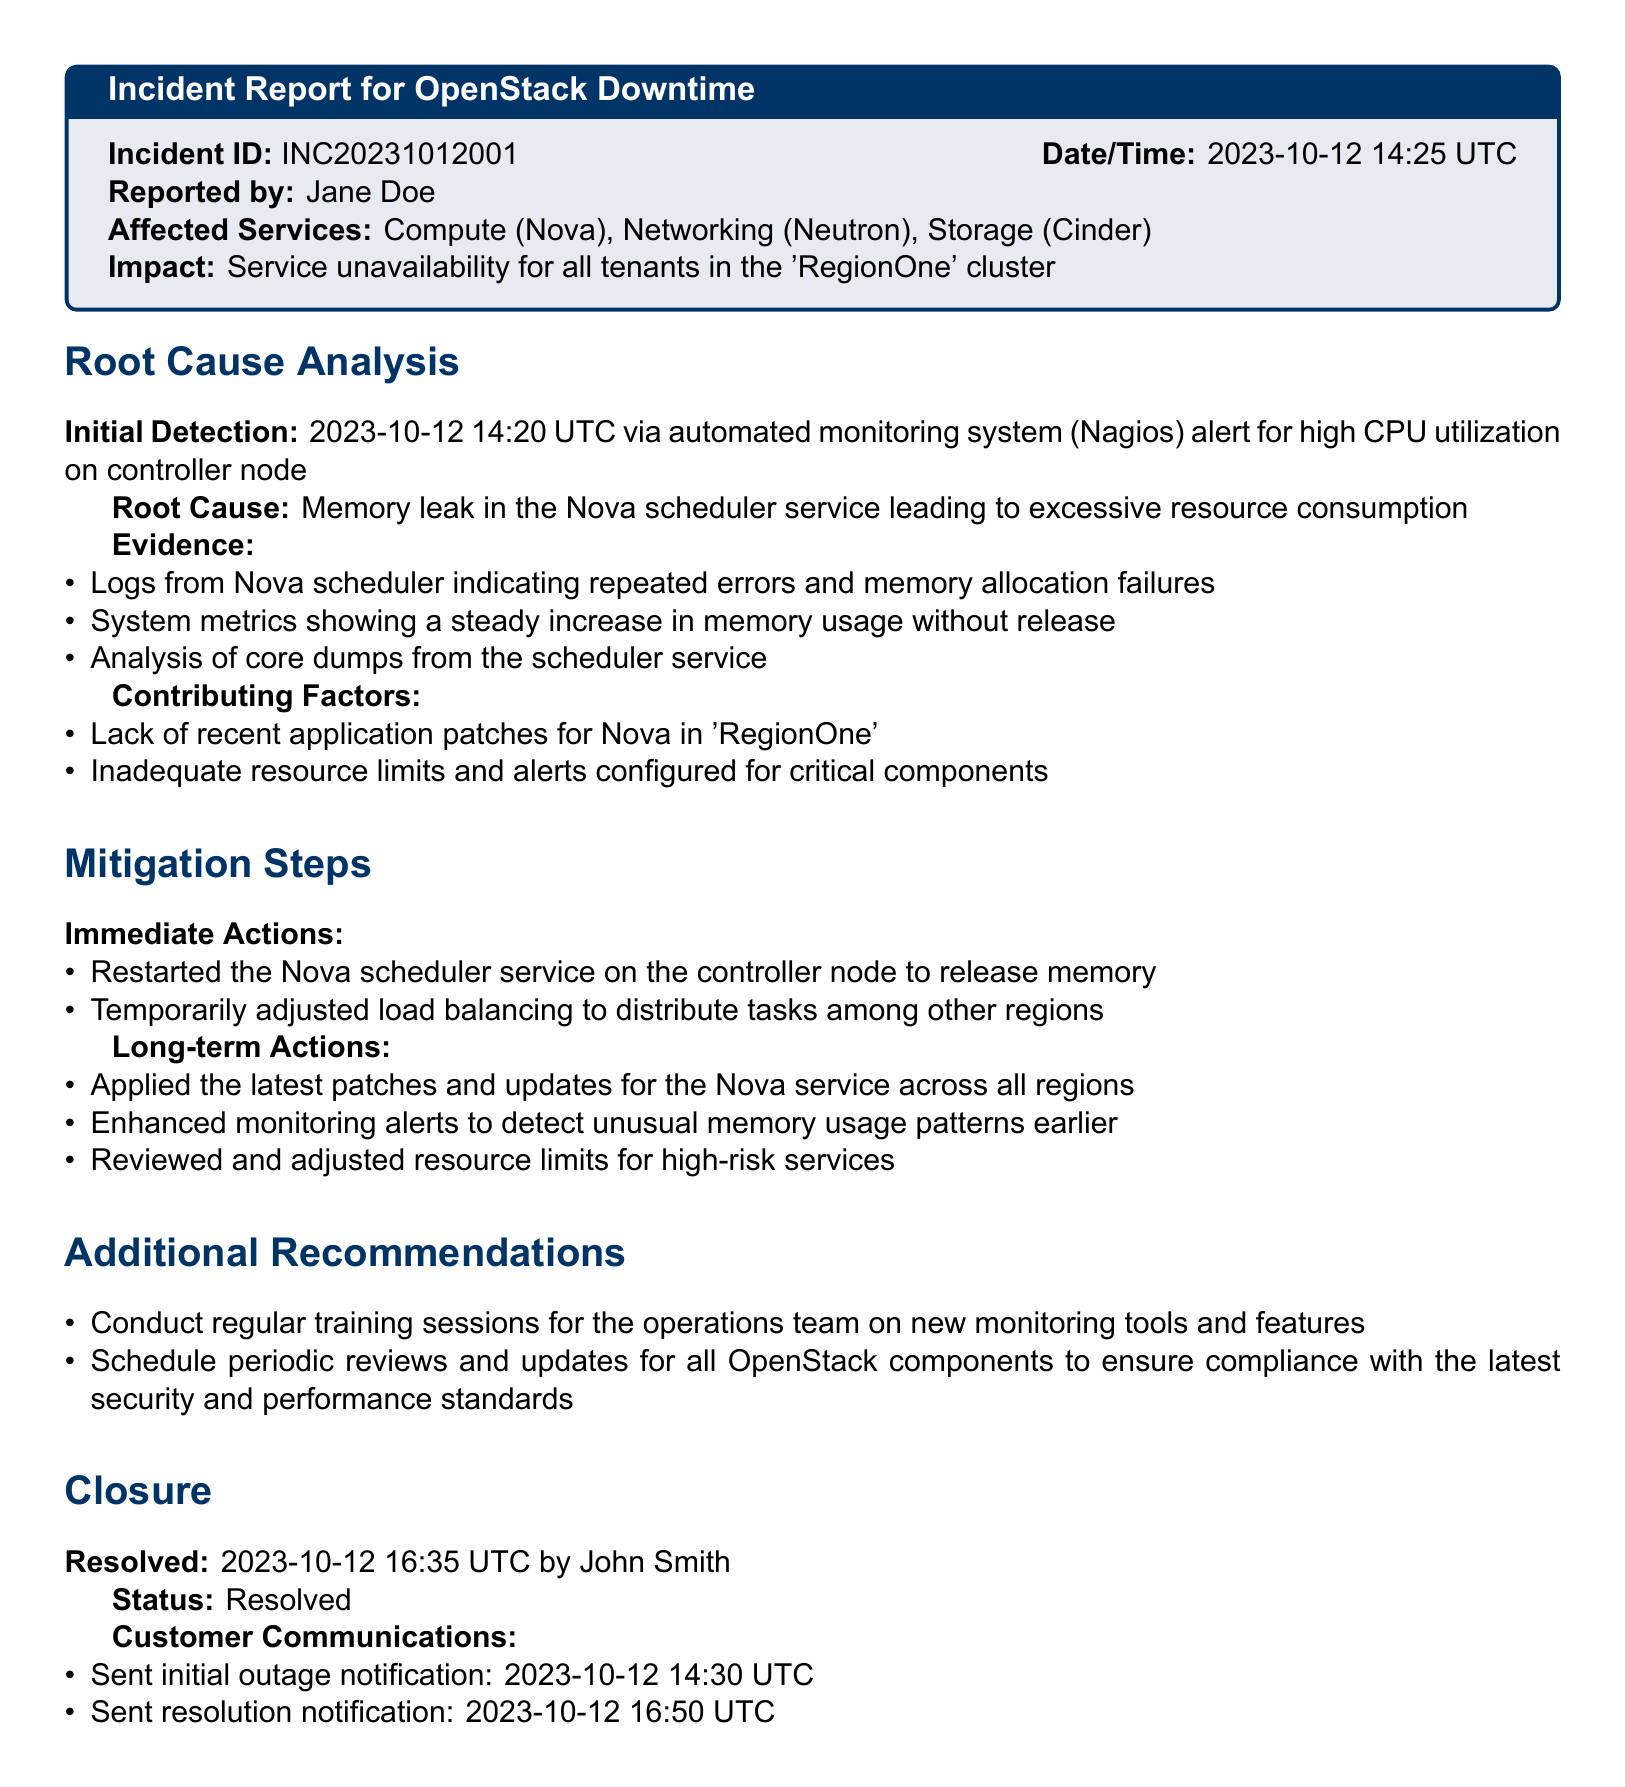What is the incident ID? The incident ID is a unique identifier for the incident, specified in the document.
Answer: INC20231012001 Who reported the incident? The person who reported the incident is named in the document.
Answer: Jane Doe When was the initial detection of the incident? The initial detection time is provided in the document.
Answer: 2023-10-12 14:20 UTC What was the root cause of the incident? The root cause is mentioned explicitly in the document details.
Answer: Memory leak in the Nova scheduler service What were the immediate actions taken? The immediate actions taken are listed in the document.
Answer: Restarted the Nova scheduler service What is the status of the incident? The status of the incident is provided towards the end of the document.
Answer: Resolved Which services were affected by the incident? The affected services are explicitly listed at the beginning of the document.
Answer: Compute (Nova), Networking (Neutron), Storage (Cinder) Who resolved the incident? The document specifies the individual who resolved the incident.
Answer: John Smith What time was the incident resolved? The resolution time is documented within the closure section.
Answer: 2023-10-12 16:35 UTC 